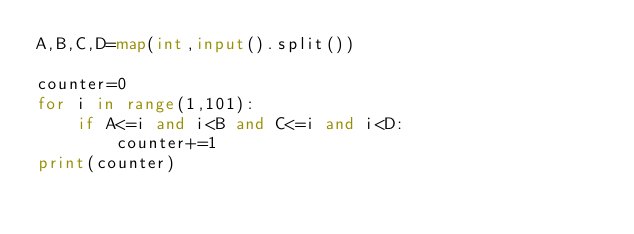<code> <loc_0><loc_0><loc_500><loc_500><_Python_>A,B,C,D=map(int,input().split())

counter=0
for i in range(1,101):
    if A<=i and i<B and C<=i and i<D:
        counter+=1
print(counter)

</code> 